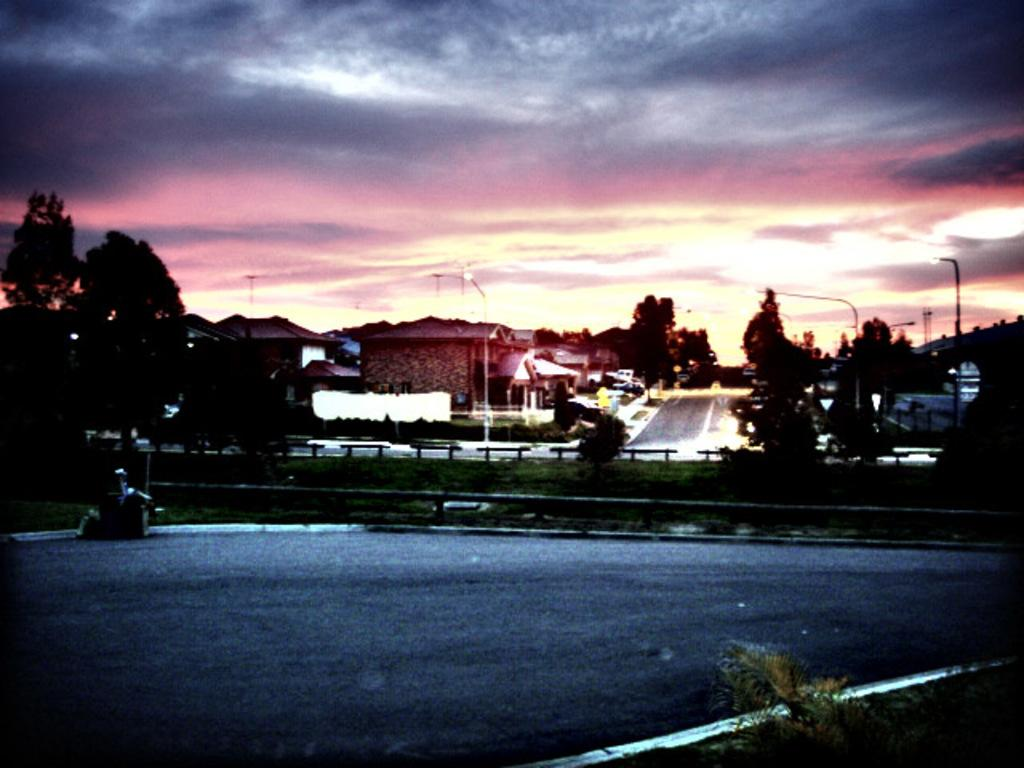What type of structures can be seen in the image? There are buildings in the image. What natural elements are present in the image? There are trees in the image. What type of man-made objects can be seen in the image? There are light poles and poles in the image. What is the primary mode of transportation in the image? There is a road in the image, which suggests that vehicles might be used for transportation. What part of the natural environment is visible in the image? The sky is visible in the image. What objects are in front in the image? There are unspecified objects in front in the image. How many robins are sitting on the chairs in the image? There are no robins or chairs present in the image. What type of recess is visible in the image? There is no recess present in the image. 